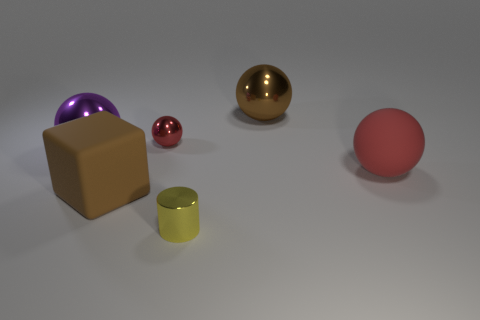What is the big brown ball made of?
Keep it short and to the point. Metal. There is a metallic object that is in front of the big purple thing; what is its color?
Provide a short and direct response. Yellow. Are there more large balls in front of the brown metal sphere than large red matte spheres that are behind the purple thing?
Make the answer very short. Yes. What is the size of the brown thing behind the large rubber object on the right side of the brown object behind the purple object?
Provide a short and direct response. Large. Are there any big shiny things of the same color as the big matte block?
Ensure brevity in your answer.  Yes. What number of small gray matte objects are there?
Provide a short and direct response. 0. What is the big sphere to the left of the large object that is behind the thing that is left of the large brown block made of?
Provide a short and direct response. Metal. Is there a large purple thing that has the same material as the brown sphere?
Make the answer very short. Yes. Is the material of the large purple sphere the same as the large brown block?
Your response must be concise. No. How many spheres are either big purple objects or big objects?
Make the answer very short. 3. 